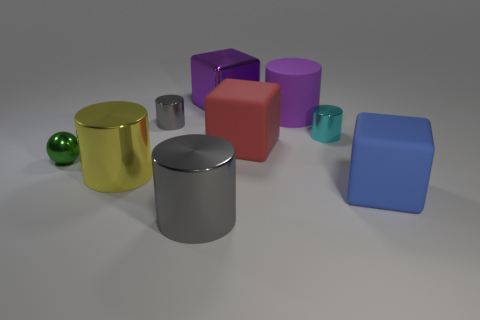Subtract all purple shiny blocks. How many blocks are left? 2 Subtract 1 cylinders. How many cylinders are left? 4 Subtract all blue cubes. How many cubes are left? 2 Subtract all cylinders. How many objects are left? 4 Subtract all green cylinders. How many yellow cubes are left? 0 Subtract all brown cubes. Subtract all tiny green shiny objects. How many objects are left? 8 Add 5 small cyan cylinders. How many small cyan cylinders are left? 6 Add 8 large blue cubes. How many large blue cubes exist? 9 Subtract 0 brown blocks. How many objects are left? 9 Subtract all gray balls. Subtract all yellow blocks. How many balls are left? 1 